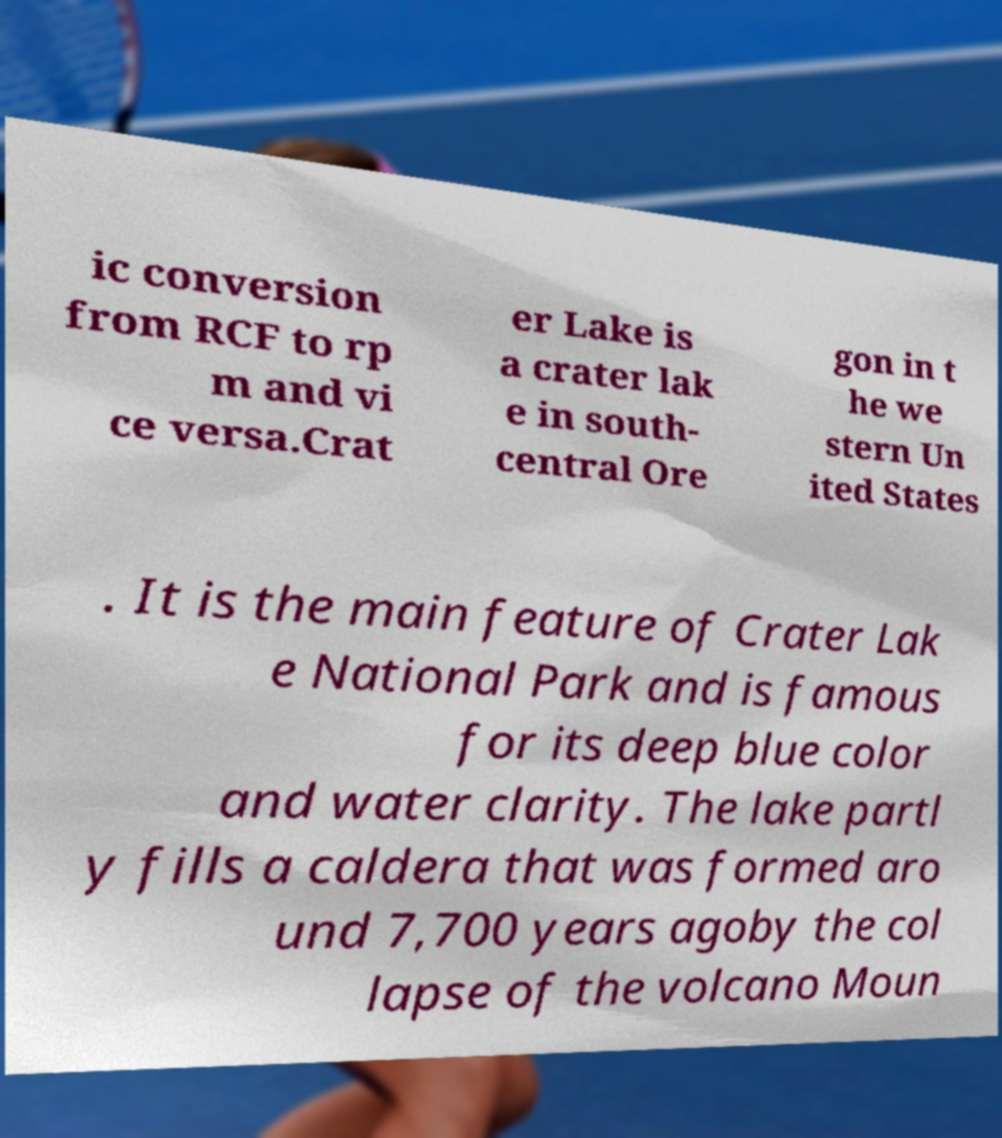For documentation purposes, I need the text within this image transcribed. Could you provide that? ic conversion from RCF to rp m and vi ce versa.Crat er Lake is a crater lak e in south- central Ore gon in t he we stern Un ited States . It is the main feature of Crater Lak e National Park and is famous for its deep blue color and water clarity. The lake partl y fills a caldera that was formed aro und 7,700 years agoby the col lapse of the volcano Moun 